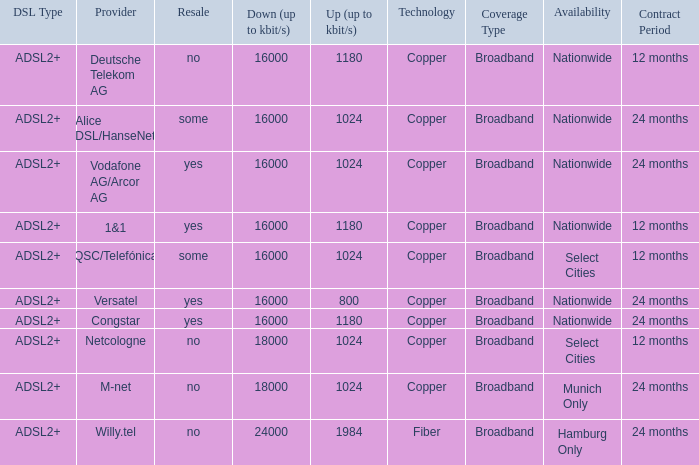What is download bandwith where the provider is deutsche telekom ag? 16000.0. 